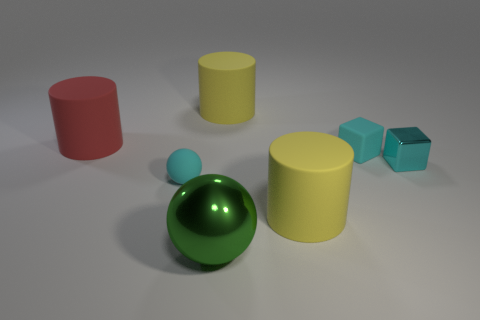Are there any patterns or consistencies in the way objects are paired by color or shape? Yes, there seems to be a pattern where objects are paired by color; the red objects are cylinders, the blue objects are different sizes of a sphere and a cube, and the yellow objects are a cylinder and a cube. 